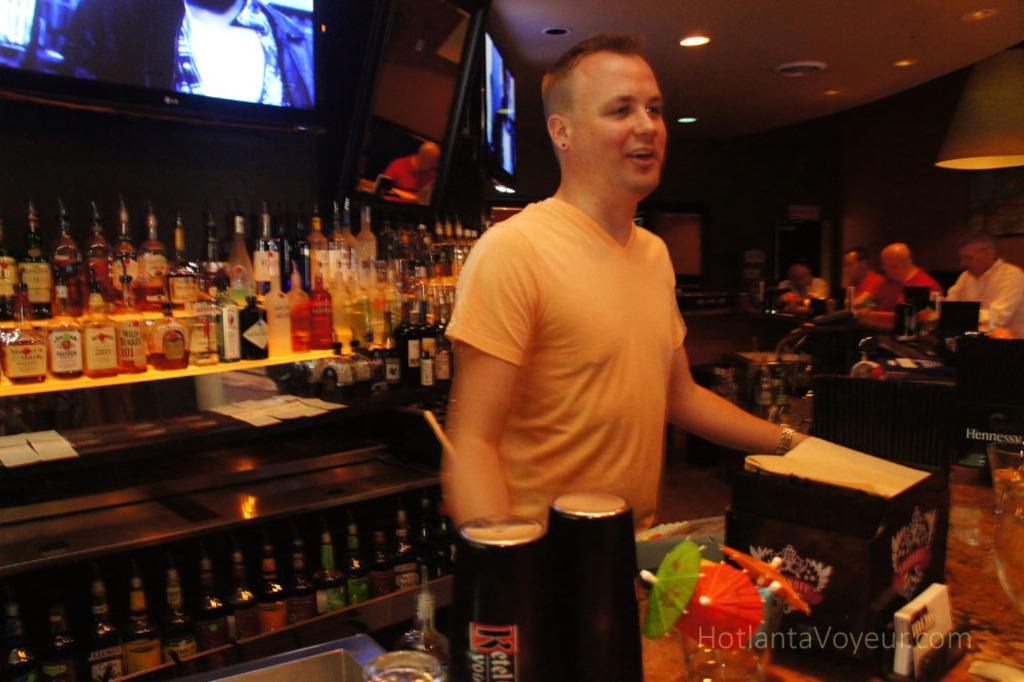Provide a one-sentence caption for the provided image. A picture that has a "hotlantavoyeur.com" on it. 